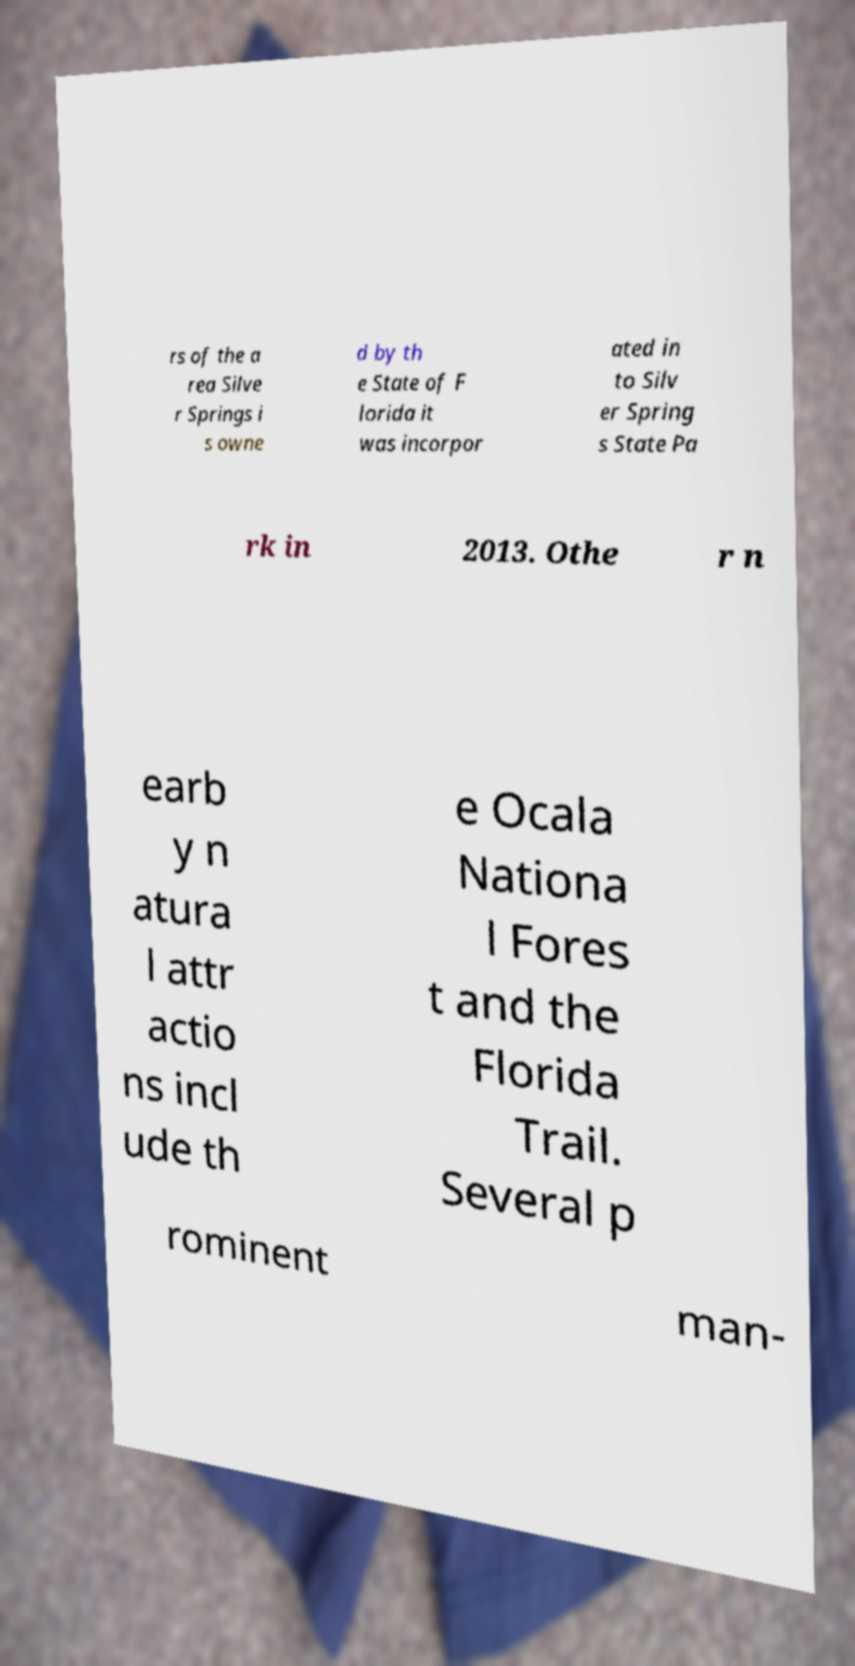Please read and relay the text visible in this image. What does it say? rs of the a rea Silve r Springs i s owne d by th e State of F lorida it was incorpor ated in to Silv er Spring s State Pa rk in 2013. Othe r n earb y n atura l attr actio ns incl ude th e Ocala Nationa l Fores t and the Florida Trail. Several p rominent man- 